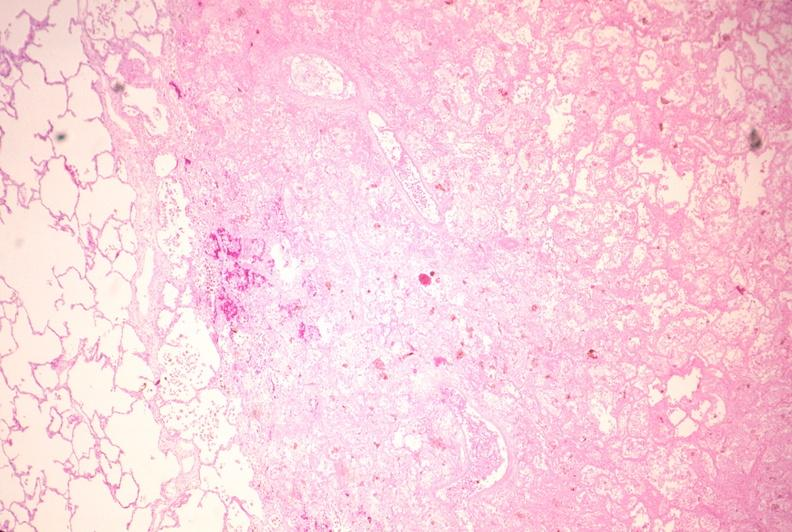s respiratory present?
Answer the question using a single word or phrase. Yes 